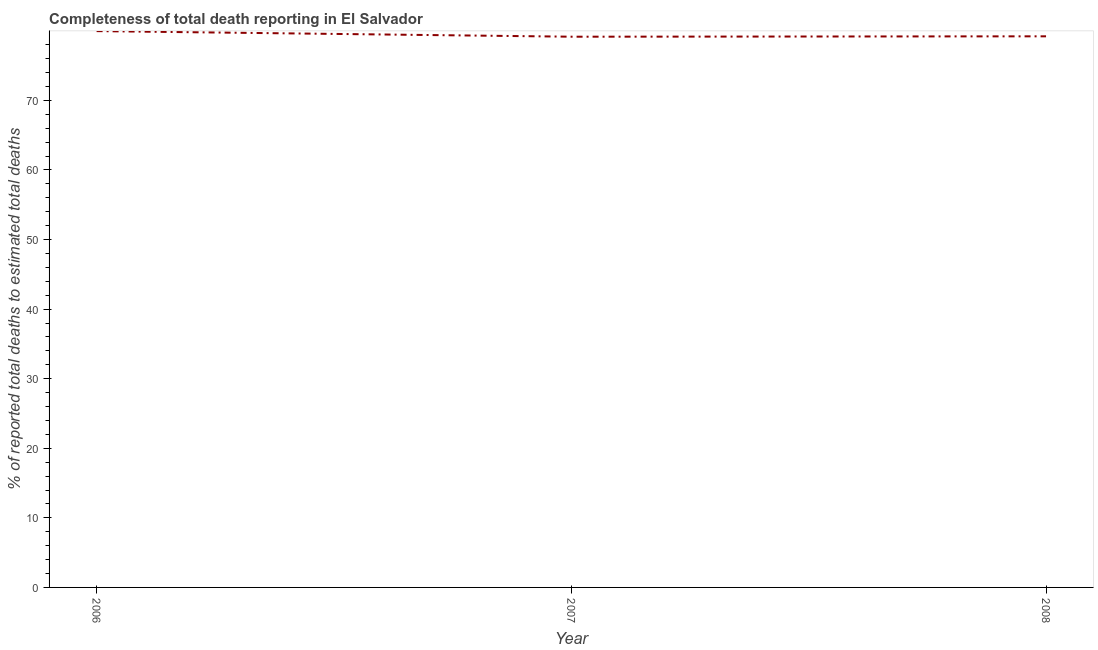What is the completeness of total death reports in 2006?
Ensure brevity in your answer.  79.96. Across all years, what is the maximum completeness of total death reports?
Keep it short and to the point. 79.96. Across all years, what is the minimum completeness of total death reports?
Offer a terse response. 79.15. In which year was the completeness of total death reports minimum?
Your answer should be very brief. 2007. What is the sum of the completeness of total death reports?
Offer a terse response. 238.32. What is the difference between the completeness of total death reports in 2006 and 2008?
Provide a succinct answer. 0.75. What is the average completeness of total death reports per year?
Offer a very short reply. 79.44. What is the median completeness of total death reports?
Your answer should be very brief. 79.21. In how many years, is the completeness of total death reports greater than 20 %?
Ensure brevity in your answer.  3. What is the ratio of the completeness of total death reports in 2006 to that in 2008?
Provide a succinct answer. 1.01. What is the difference between the highest and the second highest completeness of total death reports?
Make the answer very short. 0.75. What is the difference between the highest and the lowest completeness of total death reports?
Your answer should be compact. 0.81. In how many years, is the completeness of total death reports greater than the average completeness of total death reports taken over all years?
Make the answer very short. 1. How many years are there in the graph?
Offer a terse response. 3. Does the graph contain any zero values?
Ensure brevity in your answer.  No. What is the title of the graph?
Give a very brief answer. Completeness of total death reporting in El Salvador. What is the label or title of the X-axis?
Keep it short and to the point. Year. What is the label or title of the Y-axis?
Provide a short and direct response. % of reported total deaths to estimated total deaths. What is the % of reported total deaths to estimated total deaths of 2006?
Make the answer very short. 79.96. What is the % of reported total deaths to estimated total deaths of 2007?
Your answer should be compact. 79.15. What is the % of reported total deaths to estimated total deaths of 2008?
Provide a succinct answer. 79.21. What is the difference between the % of reported total deaths to estimated total deaths in 2006 and 2007?
Provide a short and direct response. 0.81. What is the difference between the % of reported total deaths to estimated total deaths in 2006 and 2008?
Offer a very short reply. 0.75. What is the difference between the % of reported total deaths to estimated total deaths in 2007 and 2008?
Provide a succinct answer. -0.06. What is the ratio of the % of reported total deaths to estimated total deaths in 2006 to that in 2007?
Ensure brevity in your answer.  1.01. What is the ratio of the % of reported total deaths to estimated total deaths in 2006 to that in 2008?
Provide a short and direct response. 1.01. 